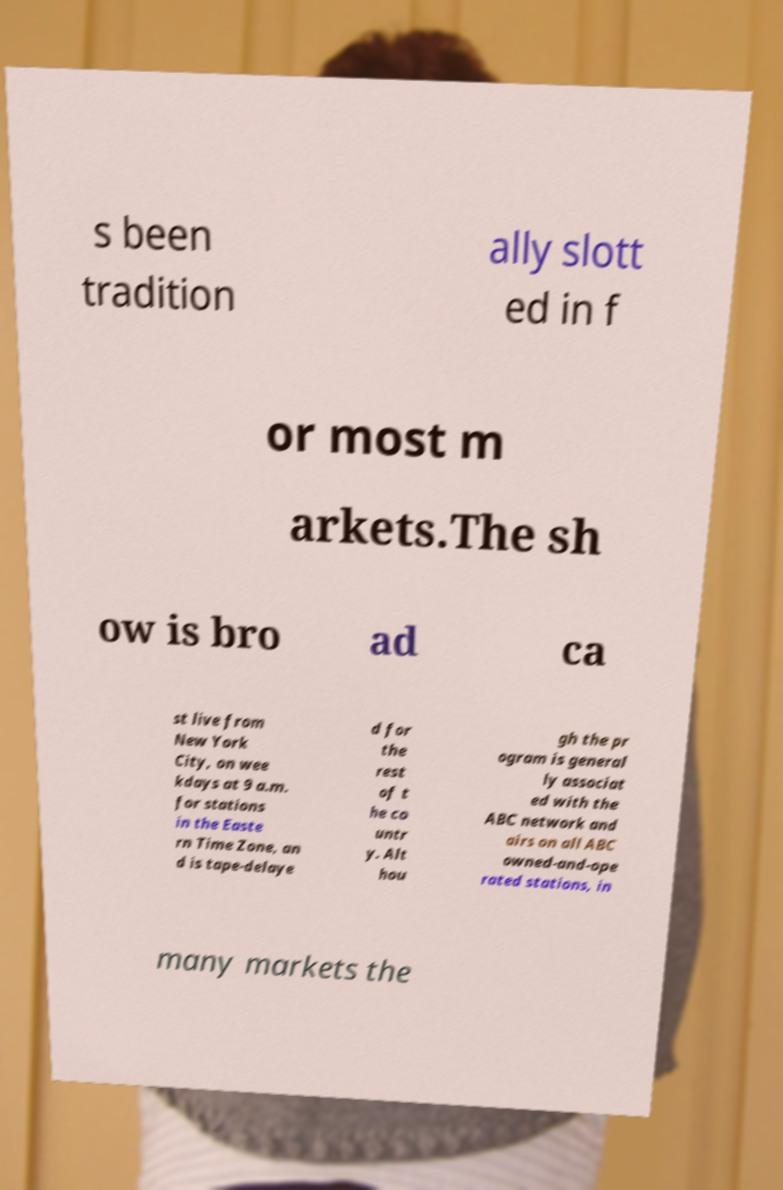Can you accurately transcribe the text from the provided image for me? s been tradition ally slott ed in f or most m arkets.The sh ow is bro ad ca st live from New York City, on wee kdays at 9 a.m. for stations in the Easte rn Time Zone, an d is tape-delaye d for the rest of t he co untr y. Alt hou gh the pr ogram is general ly associat ed with the ABC network and airs on all ABC owned-and-ope rated stations, in many markets the 